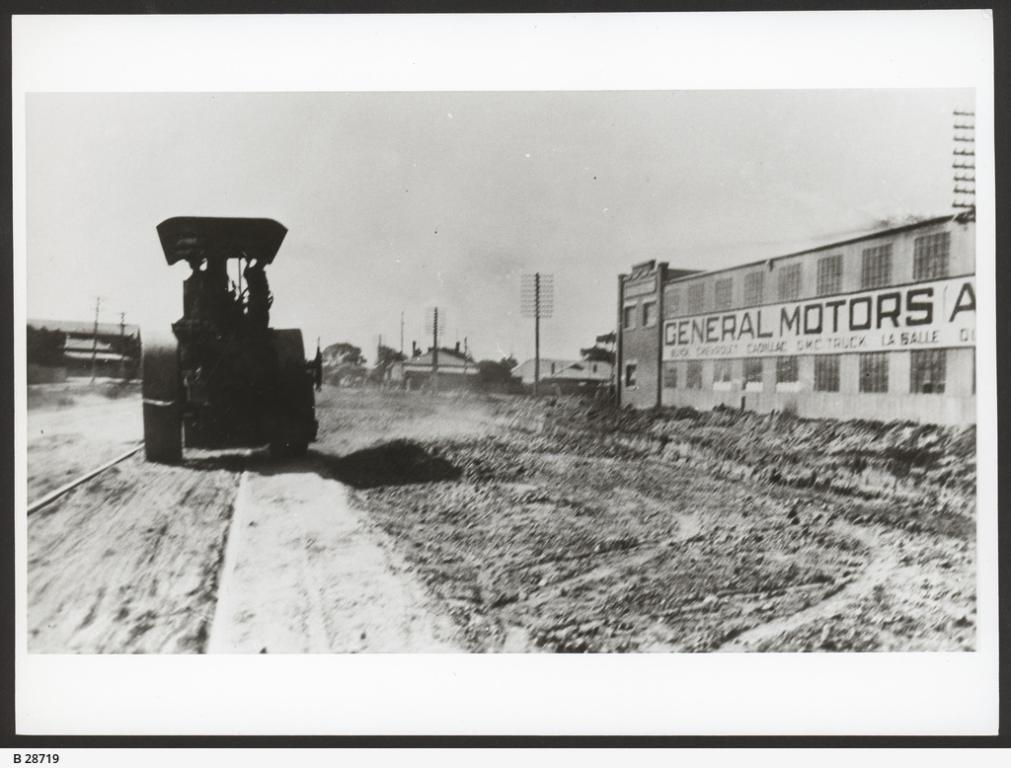Describe this image in one or two sentences. In this picture I can see the vehicle on the road. I can see houses. 